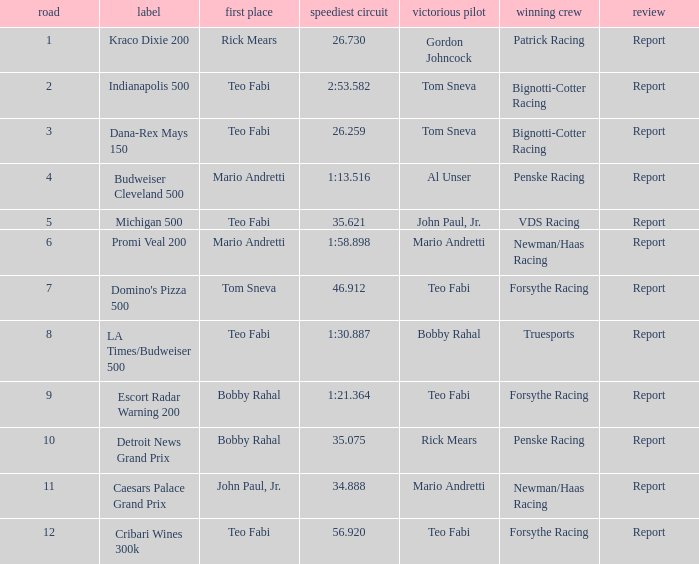Which Rd took place at the Indianapolis 500? 2.0. 